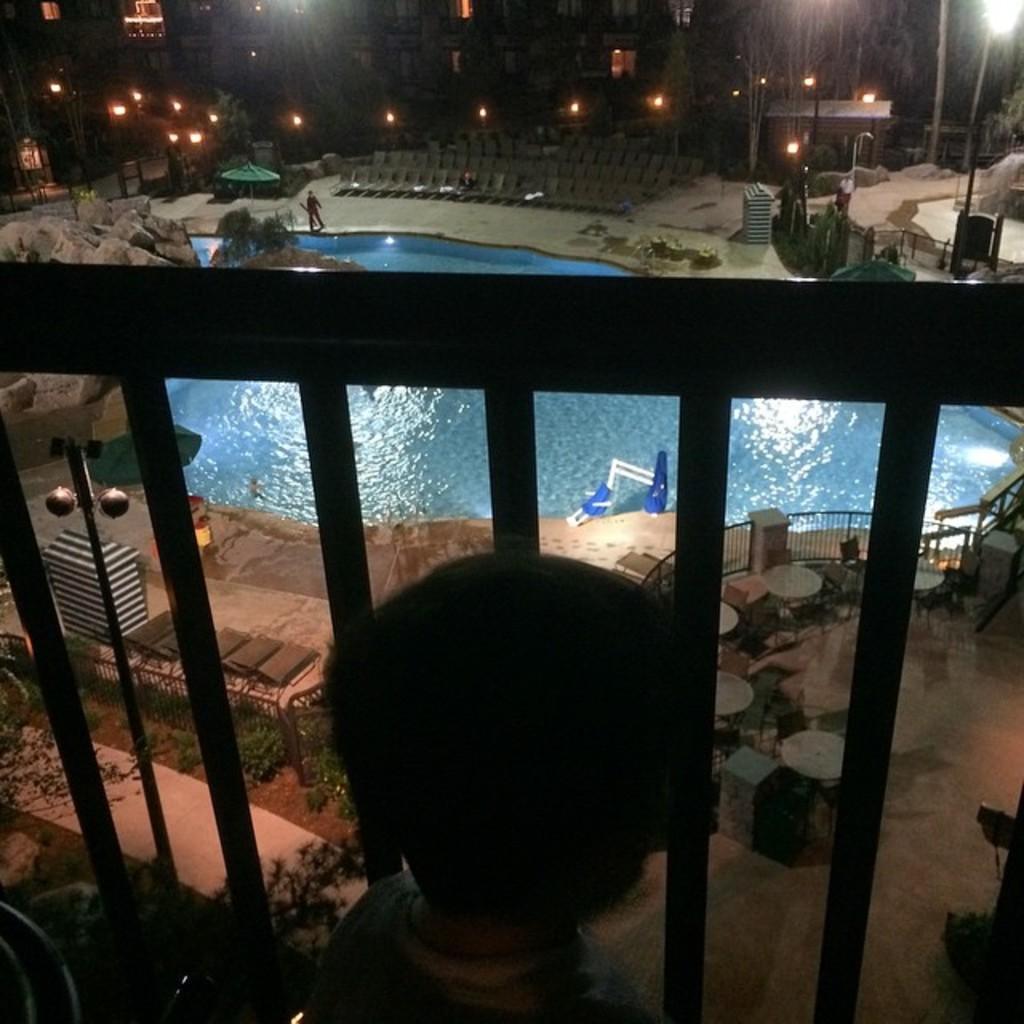Can you describe this image briefly? In this image, we can see a swimming pool. There is a safety barrier in the middle of the image. There are street poles at the top of the image. 